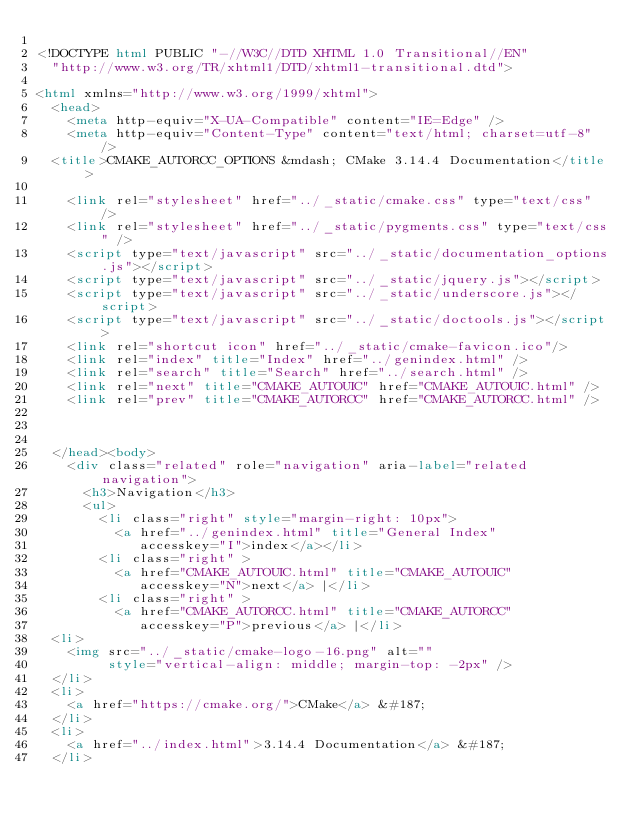Convert code to text. <code><loc_0><loc_0><loc_500><loc_500><_HTML_>
<!DOCTYPE html PUBLIC "-//W3C//DTD XHTML 1.0 Transitional//EN"
  "http://www.w3.org/TR/xhtml1/DTD/xhtml1-transitional.dtd">

<html xmlns="http://www.w3.org/1999/xhtml">
  <head>
    <meta http-equiv="X-UA-Compatible" content="IE=Edge" />
    <meta http-equiv="Content-Type" content="text/html; charset=utf-8" />
  <title>CMAKE_AUTORCC_OPTIONS &mdash; CMake 3.14.4 Documentation</title>

    <link rel="stylesheet" href="../_static/cmake.css" type="text/css" />
    <link rel="stylesheet" href="../_static/pygments.css" type="text/css" />
    <script type="text/javascript" src="../_static/documentation_options.js"></script>
    <script type="text/javascript" src="../_static/jquery.js"></script>
    <script type="text/javascript" src="../_static/underscore.js"></script>
    <script type="text/javascript" src="../_static/doctools.js"></script>
    <link rel="shortcut icon" href="../_static/cmake-favicon.ico"/>
    <link rel="index" title="Index" href="../genindex.html" />
    <link rel="search" title="Search" href="../search.html" />
    <link rel="next" title="CMAKE_AUTOUIC" href="CMAKE_AUTOUIC.html" />
    <link rel="prev" title="CMAKE_AUTORCC" href="CMAKE_AUTORCC.html" />
  
 

  </head><body>
    <div class="related" role="navigation" aria-label="related navigation">
      <h3>Navigation</h3>
      <ul>
        <li class="right" style="margin-right: 10px">
          <a href="../genindex.html" title="General Index"
             accesskey="I">index</a></li>
        <li class="right" >
          <a href="CMAKE_AUTOUIC.html" title="CMAKE_AUTOUIC"
             accesskey="N">next</a> |</li>
        <li class="right" >
          <a href="CMAKE_AUTORCC.html" title="CMAKE_AUTORCC"
             accesskey="P">previous</a> |</li>
  <li>
    <img src="../_static/cmake-logo-16.png" alt=""
         style="vertical-align: middle; margin-top: -2px" />
  </li>
  <li>
    <a href="https://cmake.org/">CMake</a> &#187;
  </li>
  <li>
    <a href="../index.html">3.14.4 Documentation</a> &#187;
  </li>
</code> 